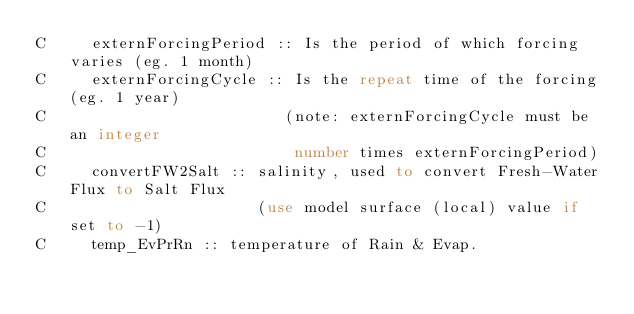Convert code to text. <code><loc_0><loc_0><loc_500><loc_500><_FORTRAN_>C     externForcingPeriod :: Is the period of which forcing varies (eg. 1 month)
C     externForcingCycle :: Is the repeat time of the forcing (eg. 1 year)
C                          (note: externForcingCycle must be an integer
C                           number times externForcingPeriod)
C     convertFW2Salt :: salinity, used to convert Fresh-Water Flux to Salt Flux
C                       (use model surface (local) value if set to -1)
C     temp_EvPrRn :: temperature of Rain & Evap.</code> 